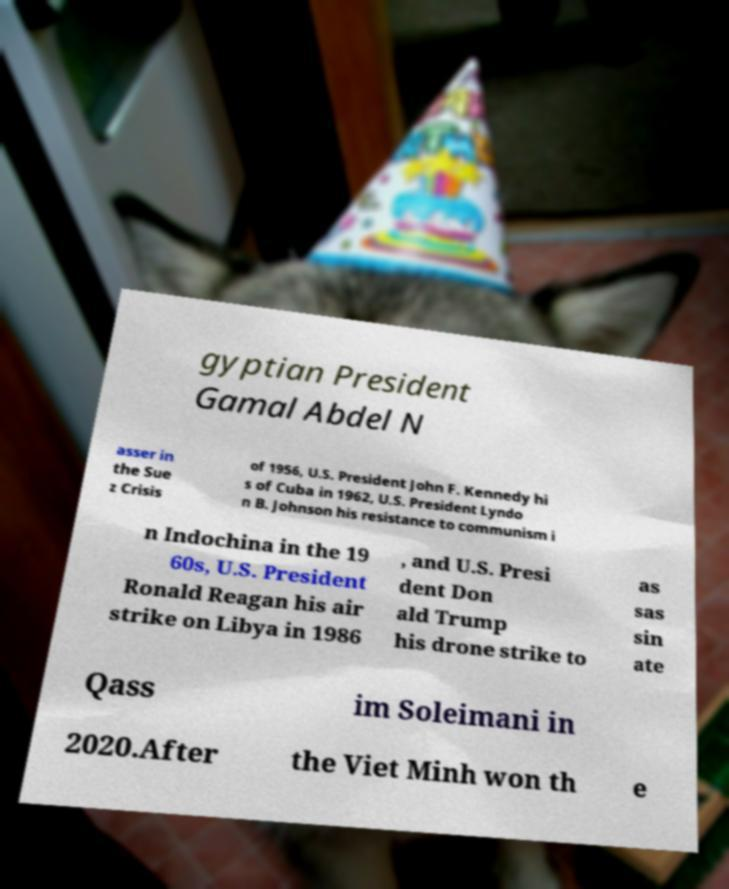There's text embedded in this image that I need extracted. Can you transcribe it verbatim? gyptian President Gamal Abdel N asser in the Sue z Crisis of 1956, U.S. President John F. Kennedy hi s of Cuba in 1962, U.S. President Lyndo n B. Johnson his resistance to communism i n Indochina in the 19 60s, U.S. President Ronald Reagan his air strike on Libya in 1986 , and U.S. Presi dent Don ald Trump his drone strike to as sas sin ate Qass im Soleimani in 2020.After the Viet Minh won th e 